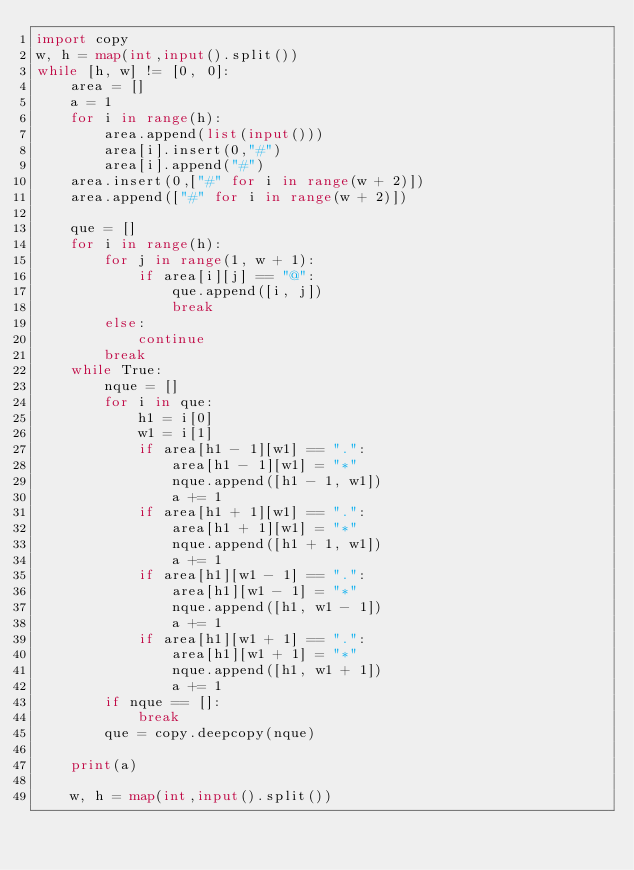Convert code to text. <code><loc_0><loc_0><loc_500><loc_500><_Python_>import copy
w, h = map(int,input().split())
while [h, w] != [0, 0]:
    area = []
    a = 1
    for i in range(h):
        area.append(list(input()))
        area[i].insert(0,"#")
        area[i].append("#")
    area.insert(0,["#" for i in range(w + 2)])
    area.append(["#" for i in range(w + 2)])

    que = []
    for i in range(h):
        for j in range(1, w + 1):
            if area[i][j] == "@":
                que.append([i, j])
                break
        else:
            continue
        break
    while True:
        nque = []
        for i in que:
            h1 = i[0]
            w1 = i[1]
            if area[h1 - 1][w1] == ".":
                area[h1 - 1][w1] = "*"
                nque.append([h1 - 1, w1])
                a += 1
            if area[h1 + 1][w1] == ".":
                area[h1 + 1][w1] = "*"
                nque.append([h1 + 1, w1])
                a += 1
            if area[h1][w1 - 1] == ".":
                area[h1][w1 - 1] = "*"
                nque.append([h1, w1 - 1])
                a += 1
            if area[h1][w1 + 1] == ".":
                area[h1][w1 + 1] = "*"
                nque.append([h1, w1 + 1])
                a += 1
        if nque == []:
            break
        que = copy.deepcopy(nque)

    print(a)
        
    w, h = map(int,input().split())
</code> 